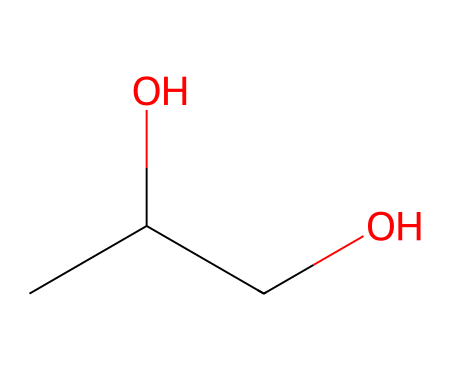What is the name of this chemical? The SMILES representation CC(O)CO corresponds to propylene glycol, which consists of two carbon atoms, one hydroxyl group, and indicates its classification as a glycol.
Answer: propylene glycol How many carbon atoms are in this molecule? The SMILES representation shows the two carbon atoms (C) in the chain, which can be seen at the start and in between the -OH groups. Count confirms a total of two carbon atoms.
Answer: 2 How many hydroxyl (−OH) groups does this molecule contain? The representation CC(O)CO reveals two hydroxyl (−OH) groups attached to the carbon atoms, as indicated by the "O" in the SMILES, confirming the presence of two -OH groups.
Answer: 2 What is the molecular formula of this chemical? From the structure indicated by the SMILES CC(O)CO, we see two carbon atoms, six hydrogen atoms, and two oxygen atoms, leading to the empirical formula C3H8O2.
Answer: C3H8O2 What type of chemical compound is propylene glycol classified as? The presence of multiple hydroxyl groups in the structure signifies it is a type of alcohol, and due to the two -OH groups, it is specifically classified as a diol or glycol.
Answer: diol Why is propylene glycol commonly used in e-liquids? This molecule has low toxicity and a safe profile for ingestion, making it suitable as a base for e-liquids, serving as a solvent for flavors and nicotine.
Answer: low toxicity 